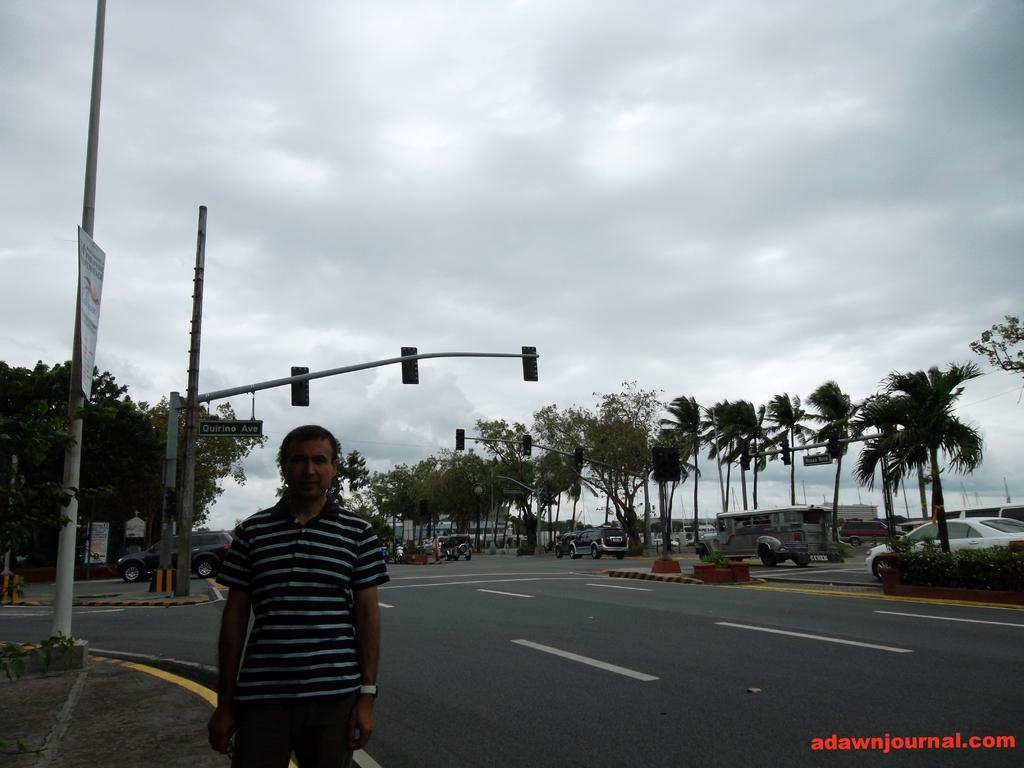Please provide a concise description of this image. In this picture we can see a man standing in the front and giving a pose to the camera. Behind there is a signal pole and some cars moving on the road. In the background we can see some trees. 